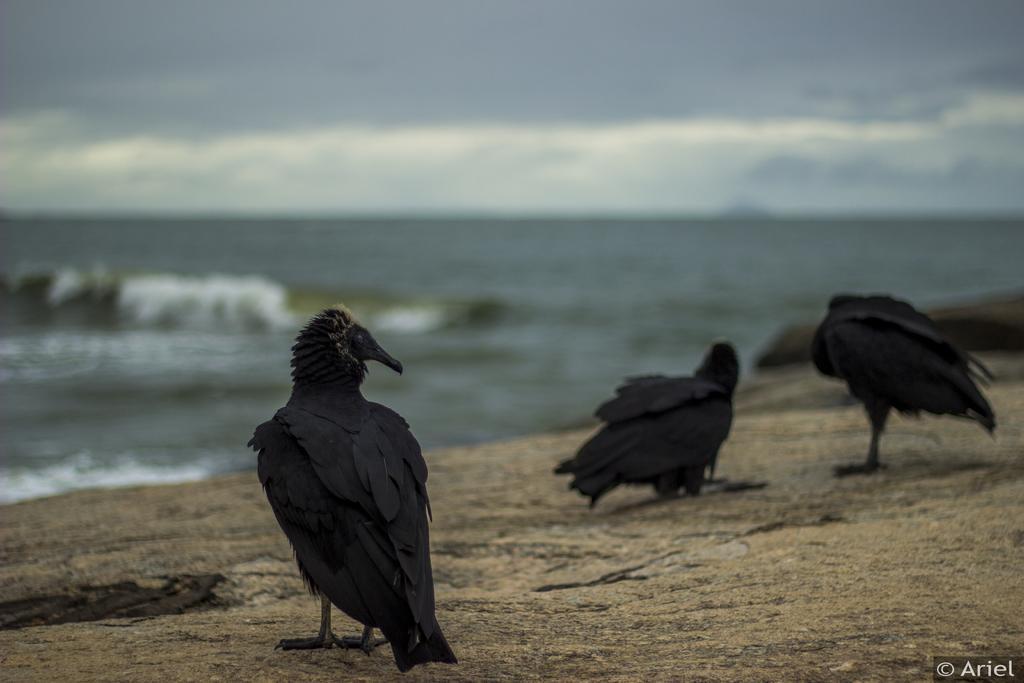In one or two sentences, can you explain what this image depicts? In this image we can see few birds. We can see the clouds in the sky. There is a sea in the image. 